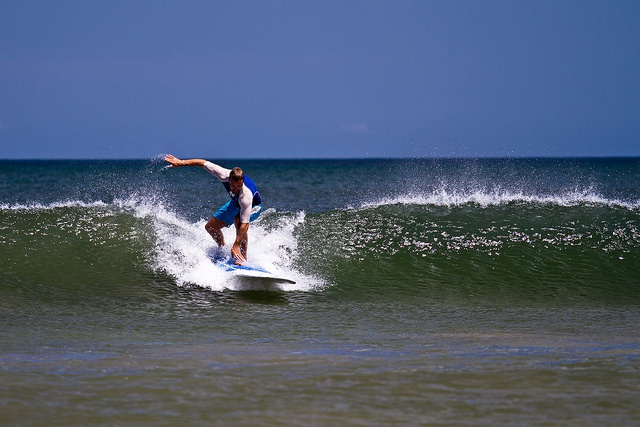Describe the objects in this image and their specific colors. I can see people in blue, black, lavender, maroon, and navy tones and surfboard in blue, lavender, darkgray, and gray tones in this image. 